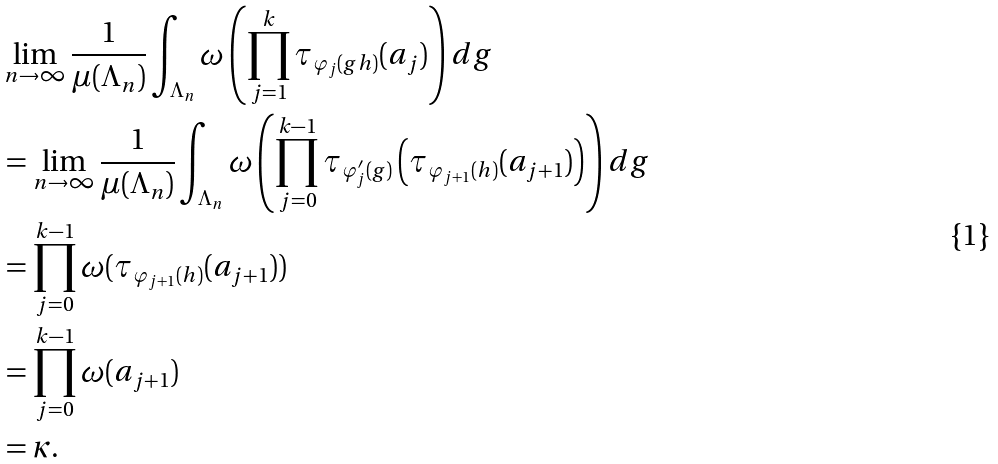Convert formula to latex. <formula><loc_0><loc_0><loc_500><loc_500>& \lim _ { n \rightarrow \infty } \frac { 1 } { \mu ( \Lambda _ { n } ) } \int _ { \Lambda _ { n } } \omega \left ( \prod _ { j = 1 } ^ { k } \tau _ { \varphi _ { j } ( g h ) } ( a _ { j } ) \right ) d g \\ & = \lim _ { n \rightarrow \infty } \frac { 1 } { \mu ( \Lambda _ { n } ) } \int _ { \Lambda _ { n } } \omega \left ( \prod _ { j = 0 } ^ { k - 1 } \tau _ { \varphi _ { j } ^ { \prime } ( g ) } \left ( \tau _ { \varphi _ { j + 1 } ( h ) } ( a _ { j + 1 } ) \right ) \right ) d g \\ & = \prod _ { j = 0 } ^ { k - 1 } \omega ( \tau _ { \varphi _ { j + 1 } ( h ) } ( a _ { j + 1 } ) ) \\ & = \prod _ { j = 0 } ^ { k - 1 } \omega ( a _ { j + 1 } ) \\ & = \kappa .</formula> 